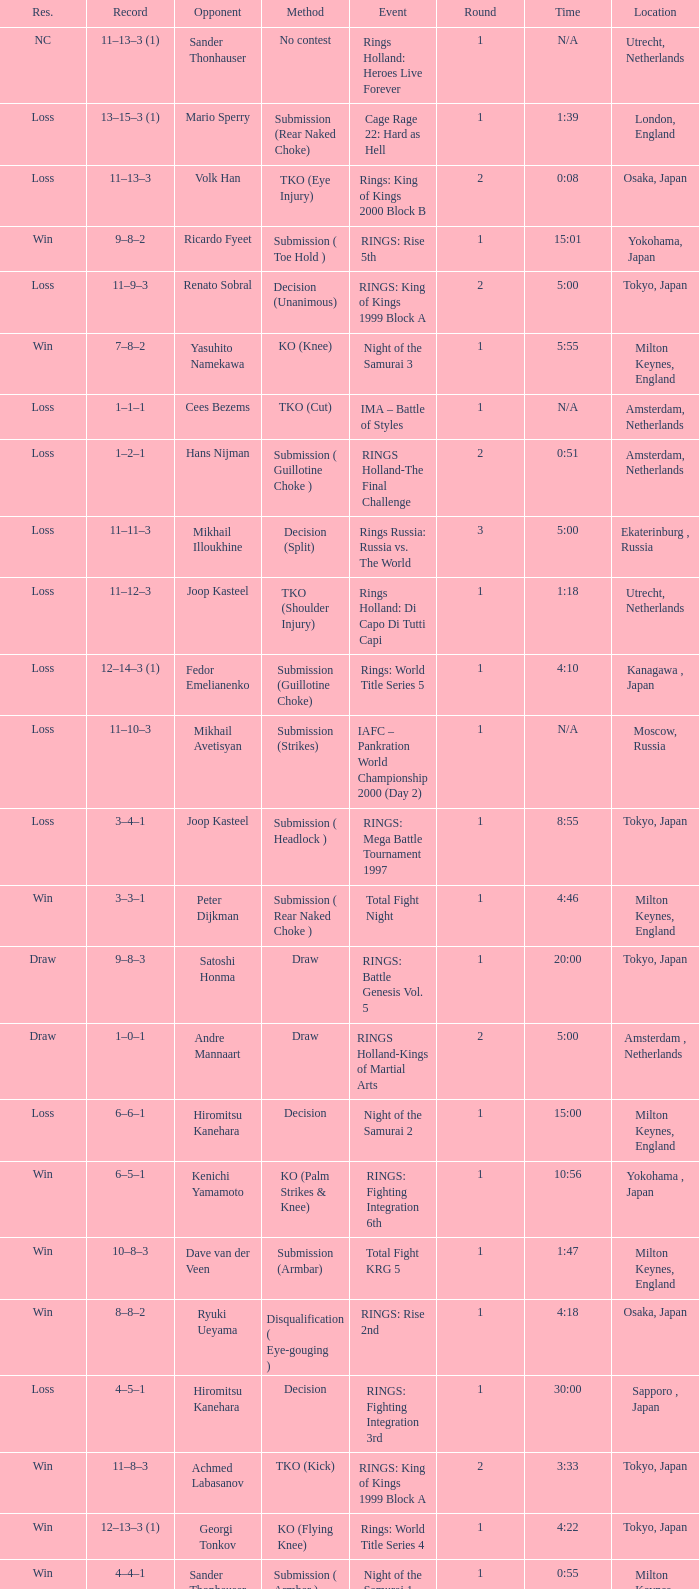What is the time for an opponent of Satoshi Honma? 20:00. 